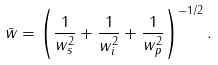Convert formula to latex. <formula><loc_0><loc_0><loc_500><loc_500>\bar { w } = \left ( \frac { 1 } { w _ { s } ^ { 2 } } + \frac { 1 } { w _ { i } ^ { 2 } } + \frac { 1 } { w _ { p } ^ { 2 } } \right ) ^ { - 1 / 2 } .</formula> 